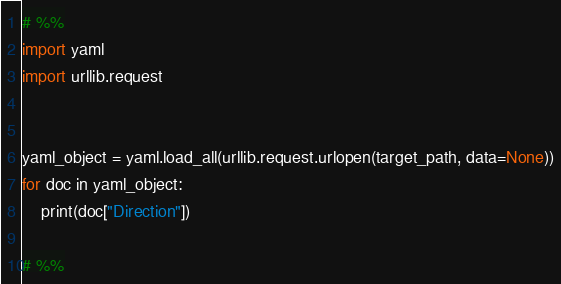<code> <loc_0><loc_0><loc_500><loc_500><_Python_># %%
import yaml
import urllib.request


yaml_object = yaml.load_all(urllib.request.urlopen(target_path, data=None))
for doc in yaml_object:
    print(doc["Direction"])

# %%</code> 